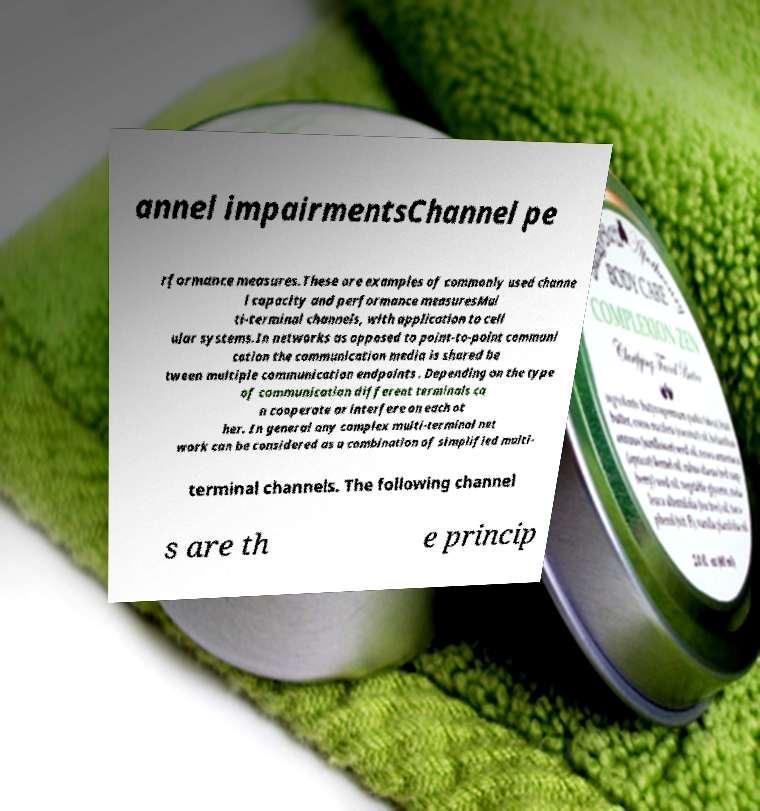I need the written content from this picture converted into text. Can you do that? annel impairmentsChannel pe rformance measures.These are examples of commonly used channe l capacity and performance measuresMul ti-terminal channels, with application to cell ular systems.In networks as opposed to point-to-point communi cation the communication media is shared be tween multiple communication endpoints . Depending on the type of communication different terminals ca n cooperate or interfere on each ot her. In general any complex multi-terminal net work can be considered as a combination of simplified multi- terminal channels. The following channel s are th e princip 